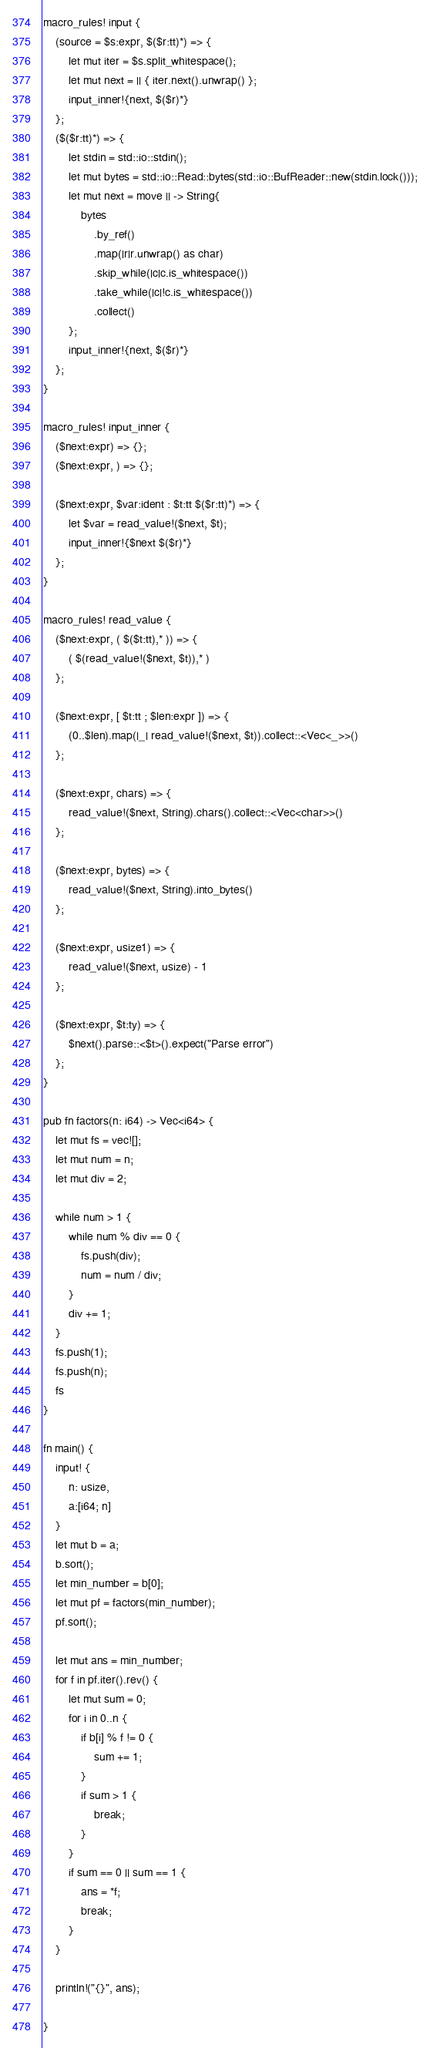Convert code to text. <code><loc_0><loc_0><loc_500><loc_500><_Rust_>macro_rules! input {
    (source = $s:expr, $($r:tt)*) => {
        let mut iter = $s.split_whitespace();
        let mut next = || { iter.next().unwrap() };
        input_inner!{next, $($r)*}
    };
    ($($r:tt)*) => {
        let stdin = std::io::stdin();
        let mut bytes = std::io::Read::bytes(std::io::BufReader::new(stdin.lock()));
        let mut next = move || -> String{
            bytes
                .by_ref()
                .map(|r|r.unwrap() as char)
                .skip_while(|c|c.is_whitespace())
                .take_while(|c|!c.is_whitespace())
                .collect()
        };
        input_inner!{next, $($r)*}
    };
}

macro_rules! input_inner {
    ($next:expr) => {};
    ($next:expr, ) => {};

    ($next:expr, $var:ident : $t:tt $($r:tt)*) => {
        let $var = read_value!($next, $t);
        input_inner!{$next $($r)*}
    };
}

macro_rules! read_value {
    ($next:expr, ( $($t:tt),* )) => {
        ( $(read_value!($next, $t)),* )
    };

    ($next:expr, [ $t:tt ; $len:expr ]) => {
        (0..$len).map(|_| read_value!($next, $t)).collect::<Vec<_>>()
    };

    ($next:expr, chars) => {
        read_value!($next, String).chars().collect::<Vec<char>>()
    };

    ($next:expr, bytes) => {
        read_value!($next, String).into_bytes()
    };

    ($next:expr, usize1) => {
        read_value!($next, usize) - 1
    };

    ($next:expr, $t:ty) => {
        $next().parse::<$t>().expect("Parse error")
    };
}

pub fn factors(n: i64) -> Vec<i64> {
    let mut fs = vec![];
    let mut num = n;
    let mut div = 2;

    while num > 1 {
        while num % div == 0 {
            fs.push(div);
            num = num / div;
        }
        div += 1;
    }
    fs.push(1);
    fs.push(n);
    fs
}

fn main() {
    input! {
        n: usize,
        a:[i64; n]
    }
    let mut b = a;
    b.sort();
    let min_number = b[0];
    let mut pf = factors(min_number);
    pf.sort();

    let mut ans = min_number; 
    for f in pf.iter().rev() {
        let mut sum = 0;
        for i in 0..n {
            if b[i] % f != 0 {
                sum += 1;
            }
            if sum > 1 {
                break;
            }
        }
        if sum == 0 || sum == 1 {
            ans = *f;
            break;
        }
    }

    println!("{}", ans);

}

</code> 